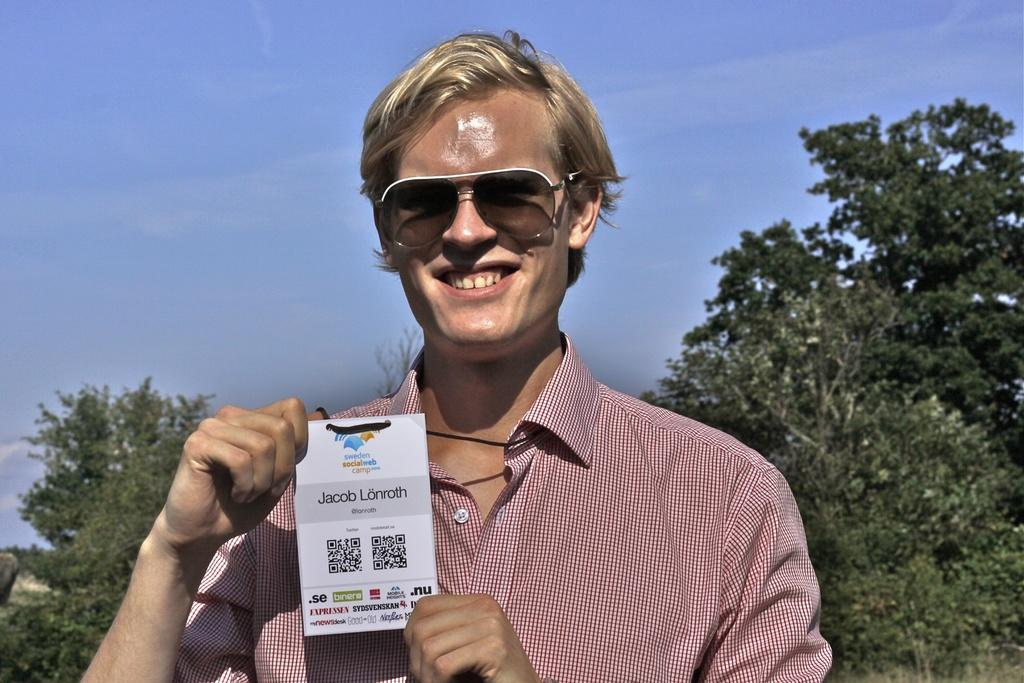What is the main subject in the foreground of the image? There is a man in the foreground of the image. What is the man holding in his hand? The man is holding a paper in his hand. What can be seen in the background of the image? There are trees and the sky visible in the background of the image. Can you describe the time of day when the image was taken? The image seems to be taken during the day. What type of jam is the man spreading on the trees in the image? There is no jam or trees being spread with jam in the image. The image features a man holding a paper in the foreground, with trees and the sky visible in the background. --- Facts: 1. There is a car in the image. 2. The car is parked on the street. 3. There are buildings in the background of the image. 4. The sky is visible in the background of the image. 5. The image seems to be taken during the day. Absurd Topics: fish, hat, dance Conversation: What is the main subject in the image? There is a car in the image. Where is the car located? The car is parked on the street. What can be seen in the background of the image? There are buildings and the sky visible in the background of the image. Can you describe the time of day when the image was taken? The image seems to be taken during the day. Reasoning: Let's think step by step in order to produce the conversation. We start by identifying the main subject in the image, which is the car. Then, we describe the location of the car, which is parked on the street. Next, we expand the conversation to include the background of the image, mentioning the buildings and the sky. Finally, we make an observation about the time of day based on the available information. Absurd Question/Answer: What type of dance is the car performing in the image? Cars do not perform dances; they are inanimate objects. The image features a car parked on the street, with buildings and the sky visible in the background. 